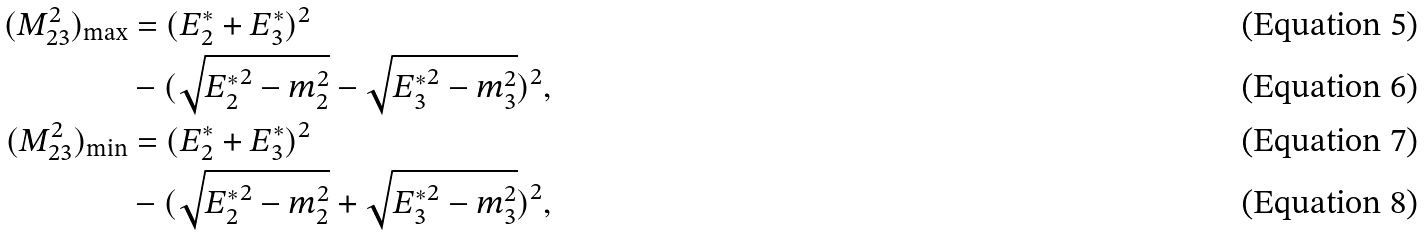Convert formula to latex. <formula><loc_0><loc_0><loc_500><loc_500>( M _ { 2 3 } ^ { 2 } ) _ { \max } & = ( E _ { 2 } ^ { * } + E _ { 3 } ^ { * } ) ^ { 2 } \\ & - ( \sqrt { { E _ { 2 } ^ { * } } ^ { 2 } - m _ { 2 } ^ { 2 } } - \sqrt { { E _ { 3 } ^ { * } } ^ { 2 } - m _ { 3 } ^ { 2 } } ) ^ { 2 } , \\ ( M _ { 2 3 } ^ { 2 } ) _ { \min } & = ( E _ { 2 } ^ { * } + E _ { 3 } ^ { * } ) ^ { 2 } \\ & - ( \sqrt { { E _ { 2 } ^ { * } } ^ { 2 } - m _ { 2 } ^ { 2 } } + \sqrt { { E _ { 3 } ^ { * } } ^ { 2 } - m _ { 3 } ^ { 2 } } ) ^ { 2 } ,</formula> 